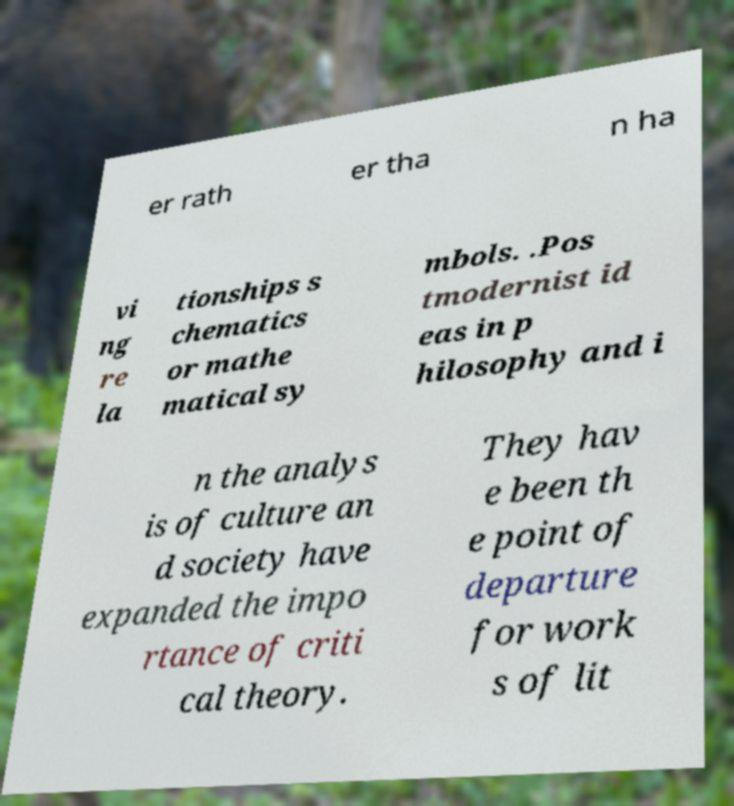Can you accurately transcribe the text from the provided image for me? er rath er tha n ha vi ng re la tionships s chematics or mathe matical sy mbols. .Pos tmodernist id eas in p hilosophy and i n the analys is of culture an d society have expanded the impo rtance of criti cal theory. They hav e been th e point of departure for work s of lit 